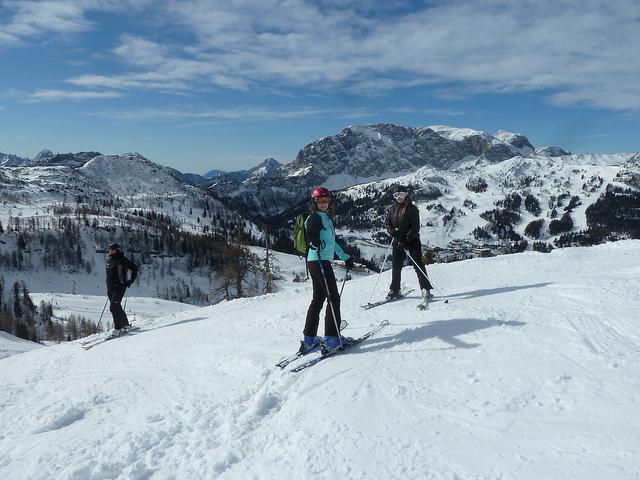Is there an overcast in the sky?
Be succinct. No. How many people is in the picture?
Write a very short answer. 3. Is the man on a snowboard?
Keep it brief. No. What color is the snow?
Be succinct. White. What sport are the people participating in?
Answer briefly. Skiing. 